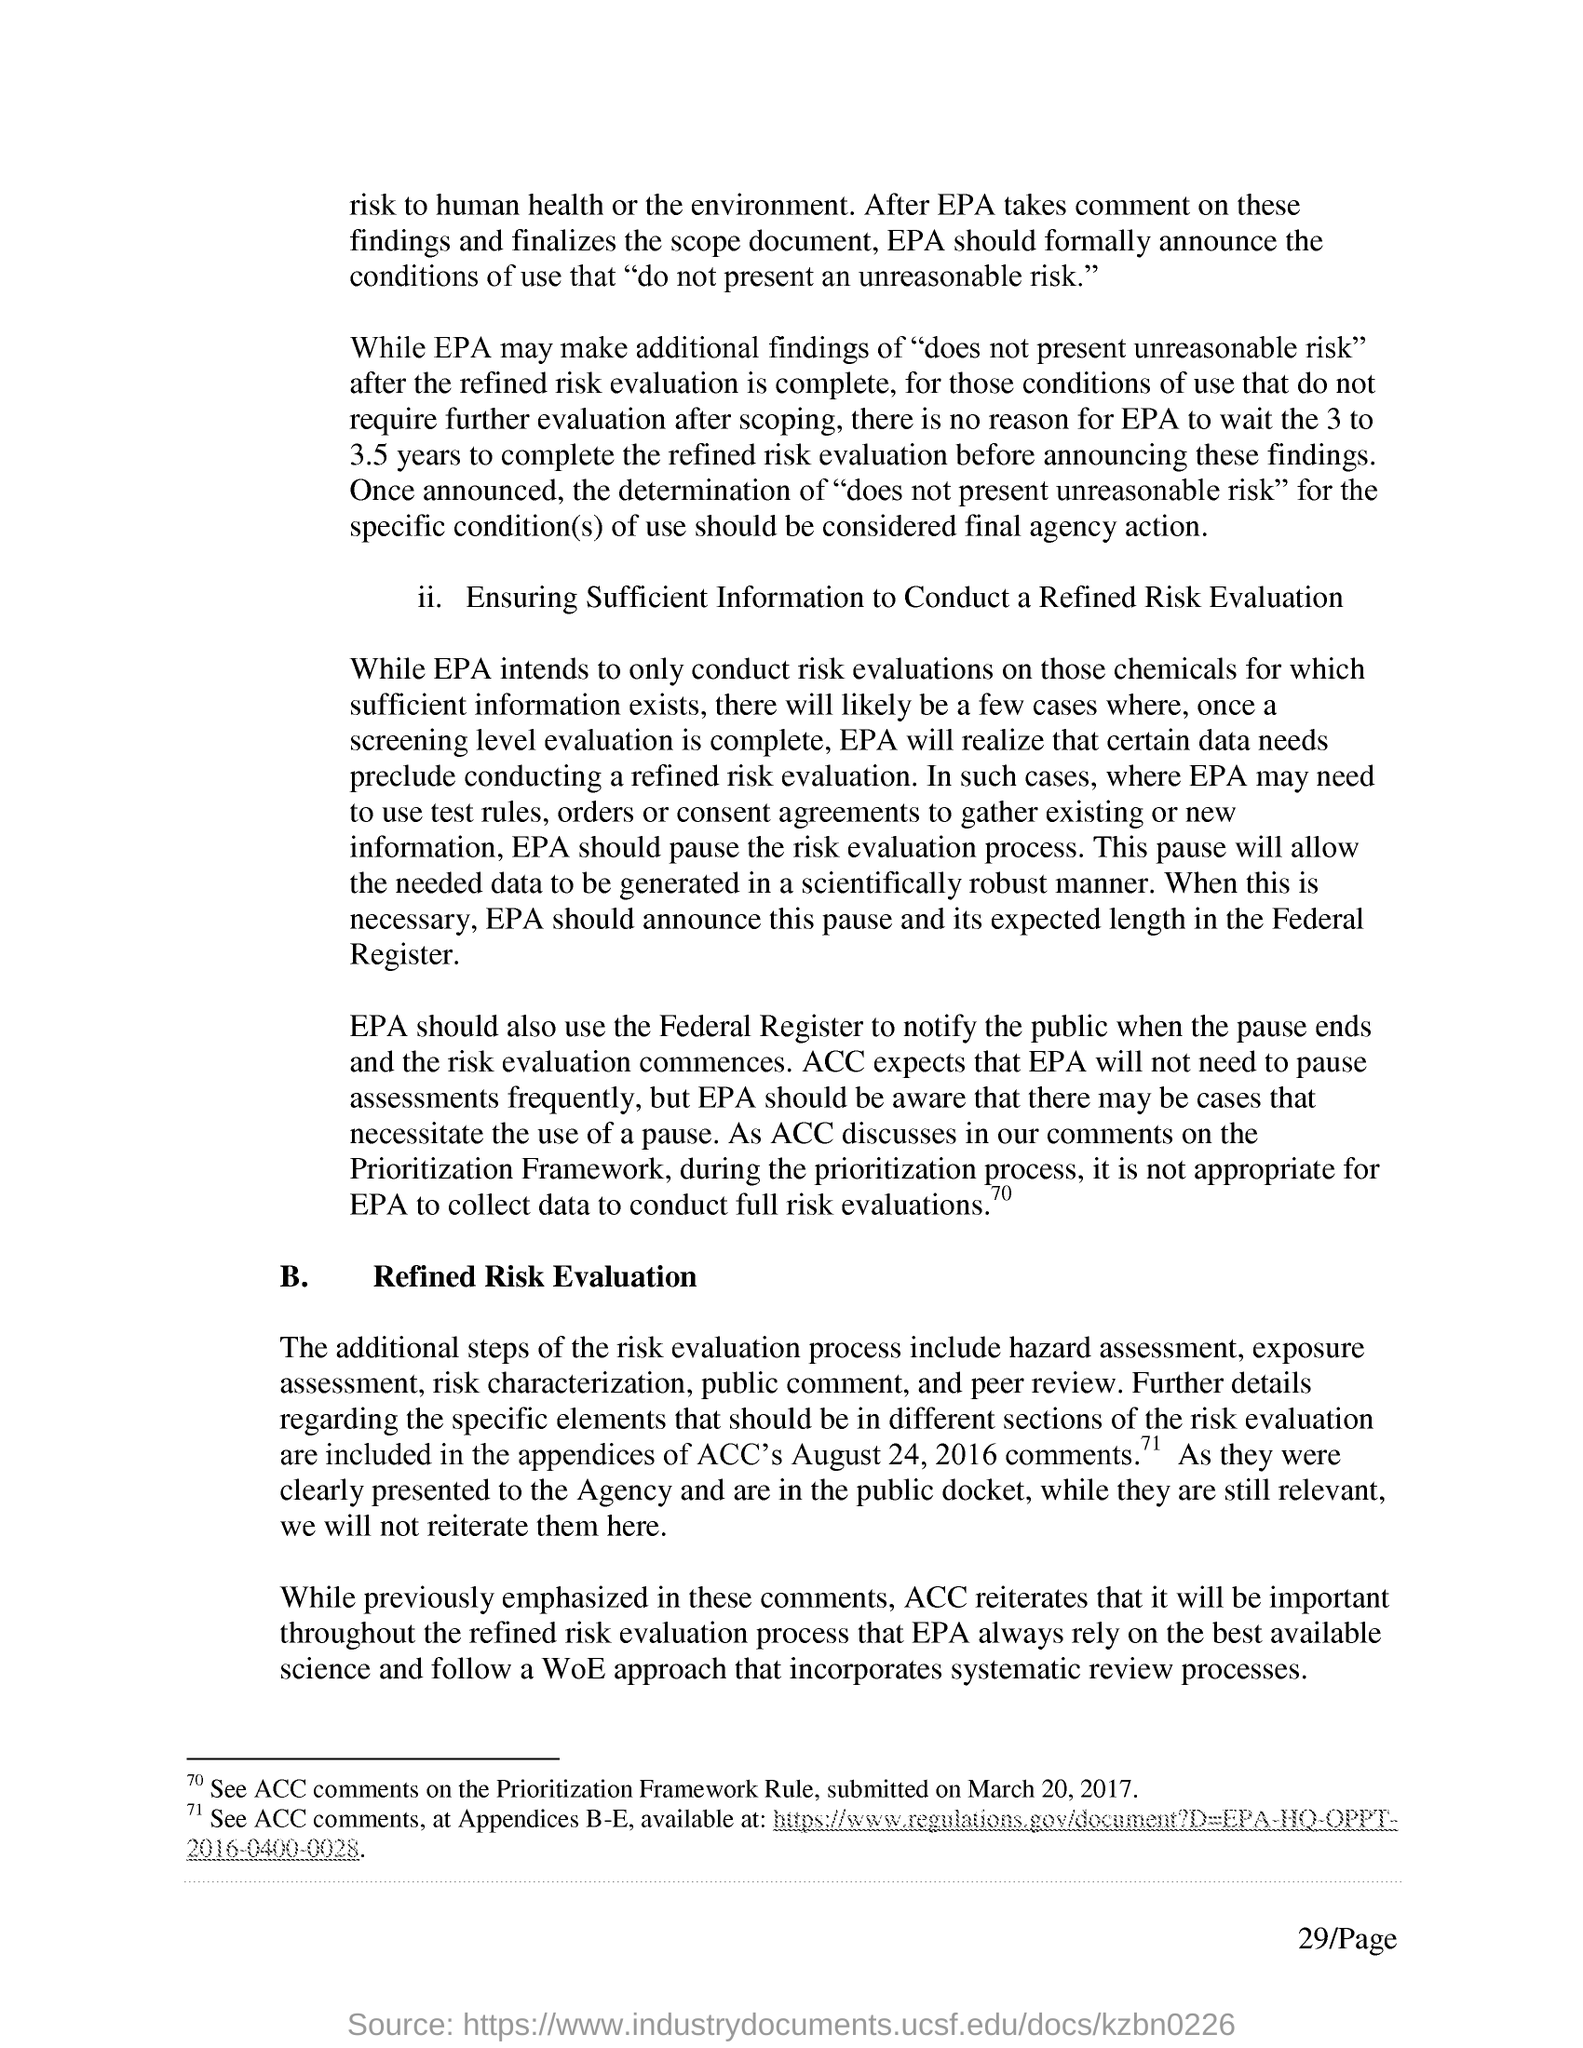Identify some key points in this picture. The page number mentioned in this document is 29. The risk evaluation process involves additional steps of hazard assessment, exposure assessment, risk characterization, public comment, and peer review. On March 20, 2017, the ACC submitted comments on the Prioritization Framework Rule. 